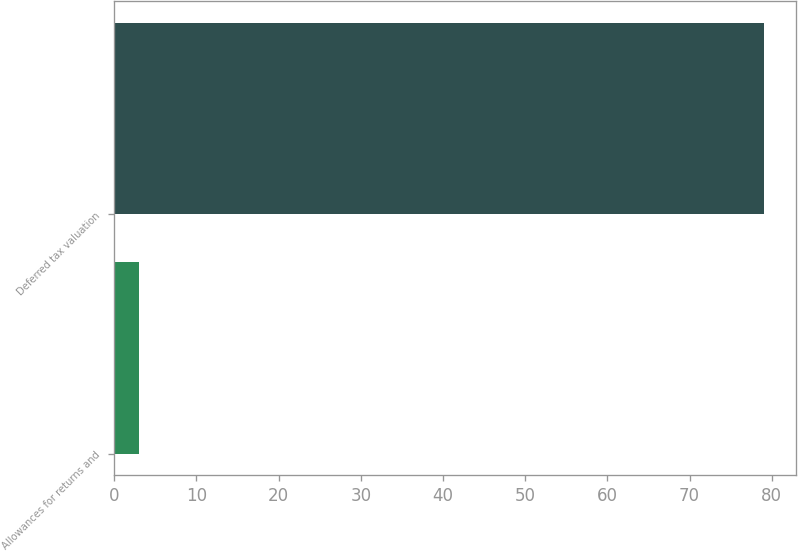<chart> <loc_0><loc_0><loc_500><loc_500><bar_chart><fcel>Allowances for returns and<fcel>Deferred tax valuation<nl><fcel>3<fcel>79<nl></chart> 